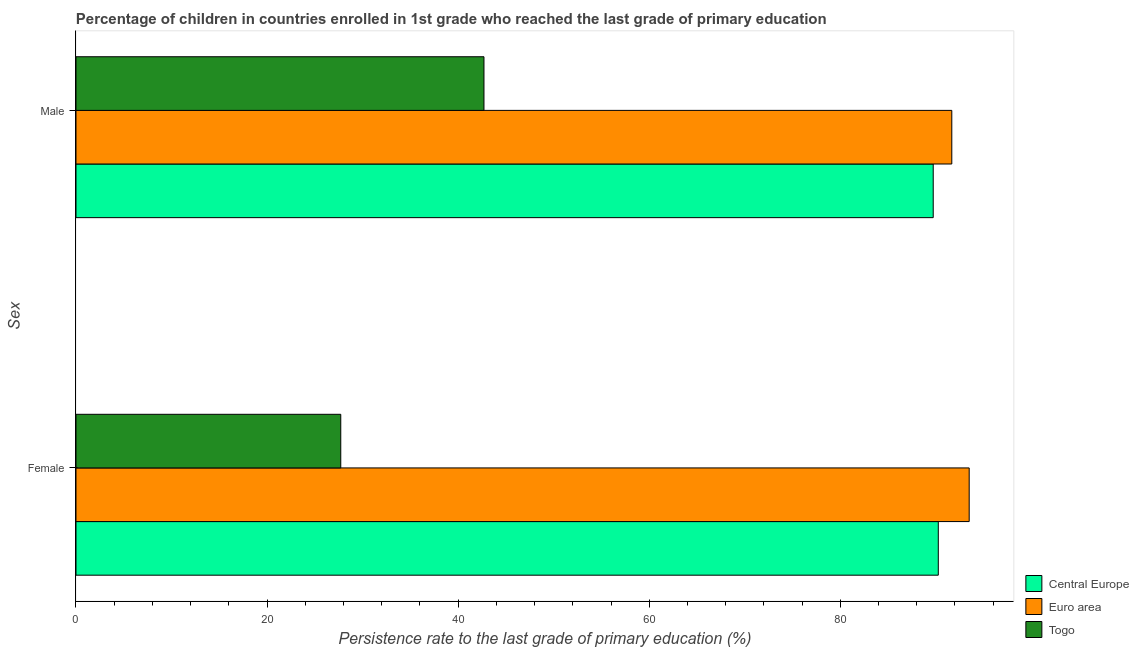Are the number of bars per tick equal to the number of legend labels?
Keep it short and to the point. Yes. How many bars are there on the 2nd tick from the top?
Provide a short and direct response. 3. What is the label of the 1st group of bars from the top?
Offer a terse response. Male. What is the persistence rate of female students in Central Europe?
Your answer should be very brief. 90.25. Across all countries, what is the maximum persistence rate of female students?
Ensure brevity in your answer.  93.49. Across all countries, what is the minimum persistence rate of male students?
Your answer should be very brief. 42.7. In which country was the persistence rate of male students minimum?
Your response must be concise. Togo. What is the total persistence rate of male students in the graph?
Offer a very short reply. 224.09. What is the difference between the persistence rate of male students in Togo and that in Euro area?
Provide a short and direct response. -48.97. What is the difference between the persistence rate of female students in Euro area and the persistence rate of male students in Central Europe?
Make the answer very short. 3.77. What is the average persistence rate of male students per country?
Provide a short and direct response. 74.7. What is the difference between the persistence rate of female students and persistence rate of male students in Togo?
Your response must be concise. -14.99. What is the ratio of the persistence rate of female students in Central Europe to that in Euro area?
Provide a short and direct response. 0.97. Is the persistence rate of female students in Togo less than that in Central Europe?
Ensure brevity in your answer.  Yes. What does the 3rd bar from the top in Female represents?
Provide a short and direct response. Central Europe. What does the 1st bar from the bottom in Male represents?
Ensure brevity in your answer.  Central Europe. How many bars are there?
Offer a terse response. 6. How many countries are there in the graph?
Give a very brief answer. 3. Are the values on the major ticks of X-axis written in scientific E-notation?
Keep it short and to the point. No. Does the graph contain grids?
Make the answer very short. No. Where does the legend appear in the graph?
Ensure brevity in your answer.  Bottom right. How many legend labels are there?
Offer a very short reply. 3. What is the title of the graph?
Keep it short and to the point. Percentage of children in countries enrolled in 1st grade who reached the last grade of primary education. What is the label or title of the X-axis?
Offer a terse response. Persistence rate to the last grade of primary education (%). What is the label or title of the Y-axis?
Your answer should be compact. Sex. What is the Persistence rate to the last grade of primary education (%) in Central Europe in Female?
Provide a succinct answer. 90.25. What is the Persistence rate to the last grade of primary education (%) of Euro area in Female?
Give a very brief answer. 93.49. What is the Persistence rate to the last grade of primary education (%) in Togo in Female?
Provide a short and direct response. 27.71. What is the Persistence rate to the last grade of primary education (%) of Central Europe in Male?
Your response must be concise. 89.72. What is the Persistence rate to the last grade of primary education (%) of Euro area in Male?
Your answer should be very brief. 91.67. What is the Persistence rate to the last grade of primary education (%) of Togo in Male?
Your answer should be very brief. 42.7. Across all Sex, what is the maximum Persistence rate to the last grade of primary education (%) in Central Europe?
Ensure brevity in your answer.  90.25. Across all Sex, what is the maximum Persistence rate to the last grade of primary education (%) of Euro area?
Provide a short and direct response. 93.49. Across all Sex, what is the maximum Persistence rate to the last grade of primary education (%) in Togo?
Your answer should be very brief. 42.7. Across all Sex, what is the minimum Persistence rate to the last grade of primary education (%) of Central Europe?
Offer a terse response. 89.72. Across all Sex, what is the minimum Persistence rate to the last grade of primary education (%) in Euro area?
Make the answer very short. 91.67. Across all Sex, what is the minimum Persistence rate to the last grade of primary education (%) of Togo?
Offer a very short reply. 27.71. What is the total Persistence rate to the last grade of primary education (%) in Central Europe in the graph?
Offer a very short reply. 179.98. What is the total Persistence rate to the last grade of primary education (%) in Euro area in the graph?
Offer a very short reply. 185.16. What is the total Persistence rate to the last grade of primary education (%) of Togo in the graph?
Provide a short and direct response. 70.42. What is the difference between the Persistence rate to the last grade of primary education (%) of Central Europe in Female and that in Male?
Your response must be concise. 0.53. What is the difference between the Persistence rate to the last grade of primary education (%) in Euro area in Female and that in Male?
Provide a short and direct response. 1.82. What is the difference between the Persistence rate to the last grade of primary education (%) in Togo in Female and that in Male?
Your answer should be very brief. -14.99. What is the difference between the Persistence rate to the last grade of primary education (%) in Central Europe in Female and the Persistence rate to the last grade of primary education (%) in Euro area in Male?
Make the answer very short. -1.41. What is the difference between the Persistence rate to the last grade of primary education (%) of Central Europe in Female and the Persistence rate to the last grade of primary education (%) of Togo in Male?
Ensure brevity in your answer.  47.55. What is the difference between the Persistence rate to the last grade of primary education (%) of Euro area in Female and the Persistence rate to the last grade of primary education (%) of Togo in Male?
Make the answer very short. 50.79. What is the average Persistence rate to the last grade of primary education (%) of Central Europe per Sex?
Your answer should be very brief. 89.99. What is the average Persistence rate to the last grade of primary education (%) in Euro area per Sex?
Offer a terse response. 92.58. What is the average Persistence rate to the last grade of primary education (%) in Togo per Sex?
Offer a terse response. 35.21. What is the difference between the Persistence rate to the last grade of primary education (%) of Central Europe and Persistence rate to the last grade of primary education (%) of Euro area in Female?
Your answer should be very brief. -3.23. What is the difference between the Persistence rate to the last grade of primary education (%) in Central Europe and Persistence rate to the last grade of primary education (%) in Togo in Female?
Offer a terse response. 62.54. What is the difference between the Persistence rate to the last grade of primary education (%) in Euro area and Persistence rate to the last grade of primary education (%) in Togo in Female?
Your answer should be very brief. 65.77. What is the difference between the Persistence rate to the last grade of primary education (%) in Central Europe and Persistence rate to the last grade of primary education (%) in Euro area in Male?
Make the answer very short. -1.95. What is the difference between the Persistence rate to the last grade of primary education (%) of Central Europe and Persistence rate to the last grade of primary education (%) of Togo in Male?
Give a very brief answer. 47.02. What is the difference between the Persistence rate to the last grade of primary education (%) in Euro area and Persistence rate to the last grade of primary education (%) in Togo in Male?
Your response must be concise. 48.97. What is the ratio of the Persistence rate to the last grade of primary education (%) of Central Europe in Female to that in Male?
Provide a short and direct response. 1.01. What is the ratio of the Persistence rate to the last grade of primary education (%) in Euro area in Female to that in Male?
Make the answer very short. 1.02. What is the ratio of the Persistence rate to the last grade of primary education (%) of Togo in Female to that in Male?
Your response must be concise. 0.65. What is the difference between the highest and the second highest Persistence rate to the last grade of primary education (%) of Central Europe?
Make the answer very short. 0.53. What is the difference between the highest and the second highest Persistence rate to the last grade of primary education (%) of Euro area?
Keep it short and to the point. 1.82. What is the difference between the highest and the second highest Persistence rate to the last grade of primary education (%) of Togo?
Give a very brief answer. 14.99. What is the difference between the highest and the lowest Persistence rate to the last grade of primary education (%) of Central Europe?
Your response must be concise. 0.53. What is the difference between the highest and the lowest Persistence rate to the last grade of primary education (%) in Euro area?
Give a very brief answer. 1.82. What is the difference between the highest and the lowest Persistence rate to the last grade of primary education (%) of Togo?
Offer a very short reply. 14.99. 